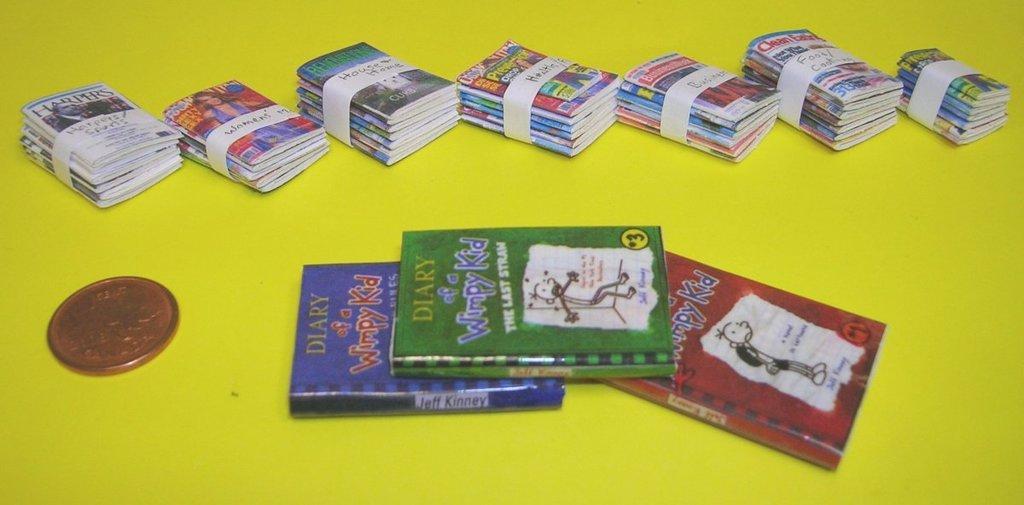In one or two sentences, can you explain what this image depicts? This image consists of many books and a coin kept on a desk. The desk is in yellow color. 